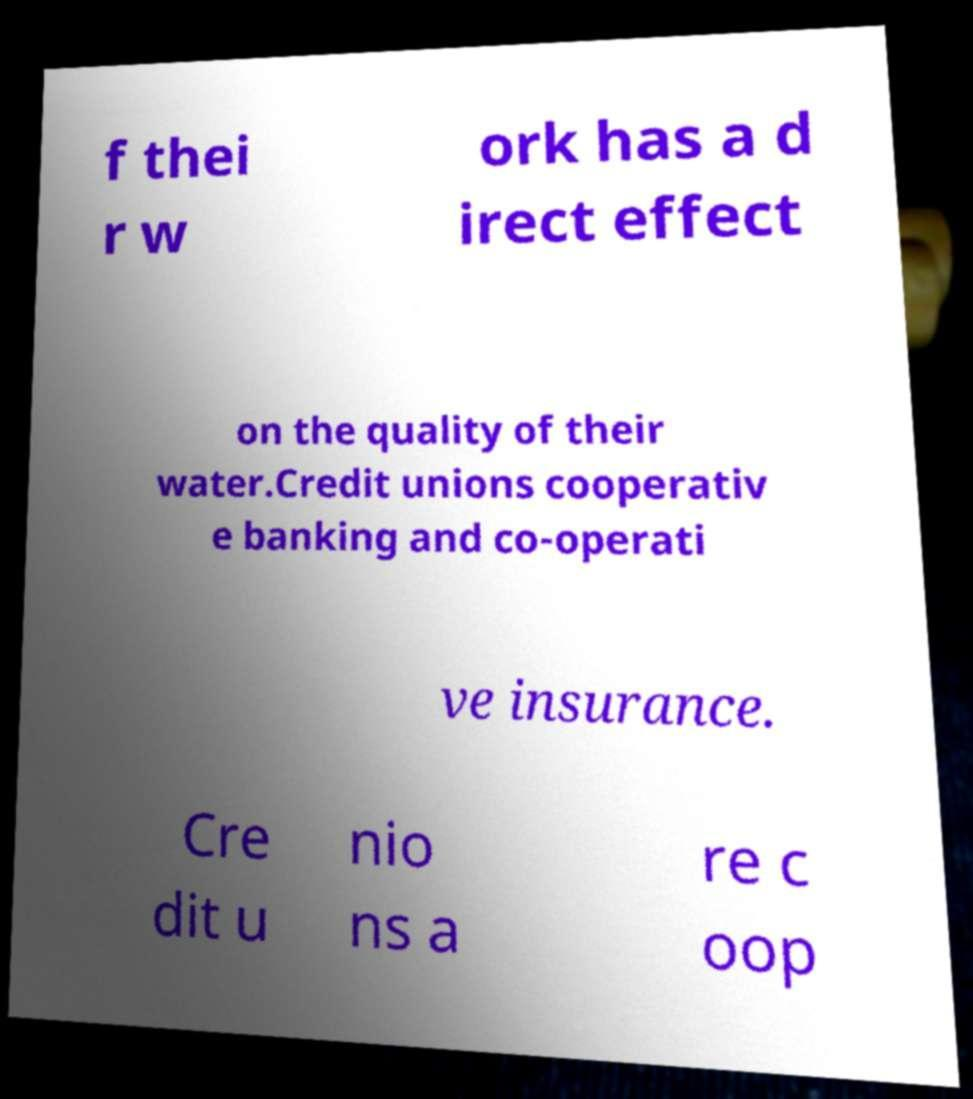Please identify and transcribe the text found in this image. f thei r w ork has a d irect effect on the quality of their water.Credit unions cooperativ e banking and co-operati ve insurance. Cre dit u nio ns a re c oop 